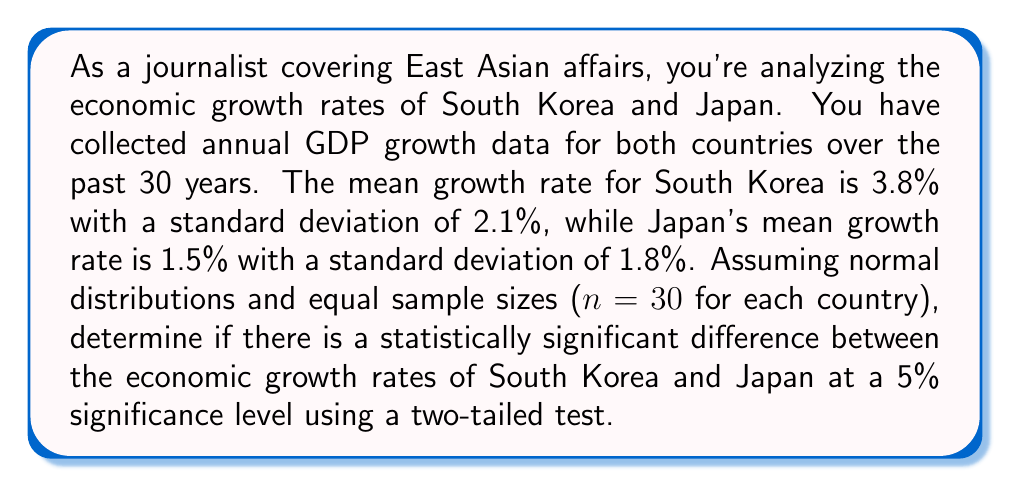Help me with this question. To determine if there's a statistically significant difference between the economic growth rates, we'll use a two-sample t-test. Here's the step-by-step process:

1. State the null and alternative hypotheses:
   $H_0: \mu_1 - \mu_2 = 0$ (no difference in mean growth rates)
   $H_a: \mu_1 - \mu_2 \neq 0$ (there is a difference in mean growth rates)

2. Calculate the pooled standard error:
   $SE = \sqrt{\frac{s_1^2}{n_1} + \frac{s_2^2}{n_2}}$
   $SE = \sqrt{\frac{2.1^2}{30} + \frac{1.8^2}{30}} = \sqrt{0.147 + 0.108} = 0.5385$

3. Calculate the t-statistic:
   $t = \frac{(\bar{x}_1 - \bar{x}_2) - (\mu_1 - \mu_2)}{SE}$
   $t = \frac{(3.8 - 1.5) - 0}{0.5385} = \frac{2.3}{0.5385} = 4.2711$

4. Determine the critical t-value:
   For a two-tailed test at 5% significance level with df = 58 (n1 + n2 - 2),
   $t_{critical} = \pm 2.002$ (from t-distribution table)

5. Compare the calculated t-statistic with the critical value:
   $|4.2711| > 2.002$, so we reject the null hypothesis.

6. Calculate the p-value:
   Using a t-distribution calculator, we find p-value $< 0.0001$

Since the p-value is less than the significance level (0.05), we reject the null hypothesis and conclude that there is a statistically significant difference between the economic growth rates of South Korea and Japan.
Answer: Reject $H_0$; statistically significant difference (p-value $< 0.0001$) 